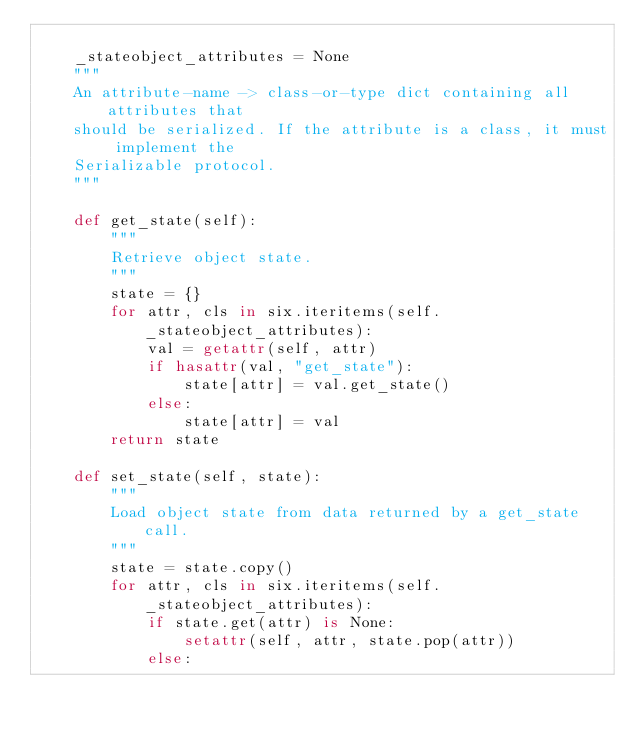<code> <loc_0><loc_0><loc_500><loc_500><_Python_>
    _stateobject_attributes = None
    """
    An attribute-name -> class-or-type dict containing all attributes that
    should be serialized. If the attribute is a class, it must implement the
    Serializable protocol.
    """

    def get_state(self):
        """
        Retrieve object state.
        """
        state = {}
        for attr, cls in six.iteritems(self._stateobject_attributes):
            val = getattr(self, attr)
            if hasattr(val, "get_state"):
                state[attr] = val.get_state()
            else:
                state[attr] = val
        return state

    def set_state(self, state):
        """
        Load object state from data returned by a get_state call.
        """
        state = state.copy()
        for attr, cls in six.iteritems(self._stateobject_attributes):
            if state.get(attr) is None:
                setattr(self, attr, state.pop(attr))
            else:</code> 